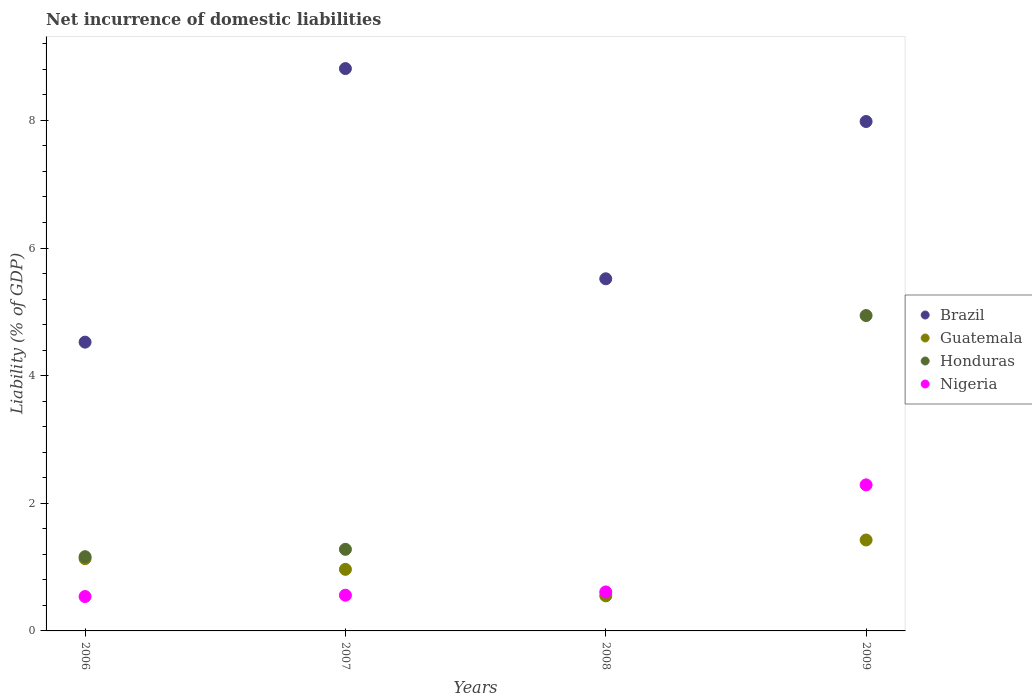How many different coloured dotlines are there?
Offer a terse response. 4. Is the number of dotlines equal to the number of legend labels?
Make the answer very short. No. What is the net incurrence of domestic liabilities in Brazil in 2009?
Make the answer very short. 7.98. Across all years, what is the maximum net incurrence of domestic liabilities in Guatemala?
Keep it short and to the point. 1.42. Across all years, what is the minimum net incurrence of domestic liabilities in Brazil?
Ensure brevity in your answer.  4.53. What is the total net incurrence of domestic liabilities in Brazil in the graph?
Offer a very short reply. 26.84. What is the difference between the net incurrence of domestic liabilities in Honduras in 2006 and that in 2009?
Provide a succinct answer. -3.78. What is the difference between the net incurrence of domestic liabilities in Brazil in 2006 and the net incurrence of domestic liabilities in Honduras in 2009?
Your answer should be compact. -0.42. What is the average net incurrence of domestic liabilities in Guatemala per year?
Provide a short and direct response. 1.02. In the year 2009, what is the difference between the net incurrence of domestic liabilities in Honduras and net incurrence of domestic liabilities in Nigeria?
Offer a very short reply. 2.65. What is the ratio of the net incurrence of domestic liabilities in Brazil in 2008 to that in 2009?
Provide a short and direct response. 0.69. Is the net incurrence of domestic liabilities in Brazil in 2006 less than that in 2009?
Offer a terse response. Yes. What is the difference between the highest and the second highest net incurrence of domestic liabilities in Guatemala?
Your answer should be compact. 0.29. What is the difference between the highest and the lowest net incurrence of domestic liabilities in Nigeria?
Make the answer very short. 1.75. Is the sum of the net incurrence of domestic liabilities in Honduras in 2007 and 2009 greater than the maximum net incurrence of domestic liabilities in Nigeria across all years?
Ensure brevity in your answer.  Yes. Does the net incurrence of domestic liabilities in Nigeria monotonically increase over the years?
Your response must be concise. Yes. Is the net incurrence of domestic liabilities in Brazil strictly greater than the net incurrence of domestic liabilities in Honduras over the years?
Your answer should be very brief. Yes. Is the net incurrence of domestic liabilities in Brazil strictly less than the net incurrence of domestic liabilities in Nigeria over the years?
Provide a short and direct response. No. What is the difference between two consecutive major ticks on the Y-axis?
Offer a terse response. 2. Are the values on the major ticks of Y-axis written in scientific E-notation?
Your answer should be very brief. No. Does the graph contain any zero values?
Your response must be concise. Yes. Does the graph contain grids?
Make the answer very short. No. How many legend labels are there?
Provide a short and direct response. 4. How are the legend labels stacked?
Provide a short and direct response. Vertical. What is the title of the graph?
Give a very brief answer. Net incurrence of domestic liabilities. Does "Papua New Guinea" appear as one of the legend labels in the graph?
Keep it short and to the point. No. What is the label or title of the X-axis?
Make the answer very short. Years. What is the label or title of the Y-axis?
Offer a terse response. Liability (% of GDP). What is the Liability (% of GDP) in Brazil in 2006?
Make the answer very short. 4.53. What is the Liability (% of GDP) of Guatemala in 2006?
Provide a short and direct response. 1.13. What is the Liability (% of GDP) of Honduras in 2006?
Keep it short and to the point. 1.16. What is the Liability (% of GDP) of Nigeria in 2006?
Offer a very short reply. 0.54. What is the Liability (% of GDP) in Brazil in 2007?
Offer a very short reply. 8.81. What is the Liability (% of GDP) in Guatemala in 2007?
Provide a short and direct response. 0.96. What is the Liability (% of GDP) in Honduras in 2007?
Keep it short and to the point. 1.28. What is the Liability (% of GDP) of Nigeria in 2007?
Give a very brief answer. 0.56. What is the Liability (% of GDP) in Brazil in 2008?
Keep it short and to the point. 5.52. What is the Liability (% of GDP) in Guatemala in 2008?
Give a very brief answer. 0.55. What is the Liability (% of GDP) in Honduras in 2008?
Provide a succinct answer. 0. What is the Liability (% of GDP) of Nigeria in 2008?
Make the answer very short. 0.61. What is the Liability (% of GDP) of Brazil in 2009?
Ensure brevity in your answer.  7.98. What is the Liability (% of GDP) in Guatemala in 2009?
Keep it short and to the point. 1.42. What is the Liability (% of GDP) of Honduras in 2009?
Make the answer very short. 4.94. What is the Liability (% of GDP) in Nigeria in 2009?
Offer a very short reply. 2.29. Across all years, what is the maximum Liability (% of GDP) in Brazil?
Keep it short and to the point. 8.81. Across all years, what is the maximum Liability (% of GDP) of Guatemala?
Your answer should be compact. 1.42. Across all years, what is the maximum Liability (% of GDP) in Honduras?
Your answer should be compact. 4.94. Across all years, what is the maximum Liability (% of GDP) of Nigeria?
Make the answer very short. 2.29. Across all years, what is the minimum Liability (% of GDP) in Brazil?
Give a very brief answer. 4.53. Across all years, what is the minimum Liability (% of GDP) in Guatemala?
Keep it short and to the point. 0.55. Across all years, what is the minimum Liability (% of GDP) of Nigeria?
Provide a succinct answer. 0.54. What is the total Liability (% of GDP) of Brazil in the graph?
Your answer should be very brief. 26.84. What is the total Liability (% of GDP) of Guatemala in the graph?
Your response must be concise. 4.07. What is the total Liability (% of GDP) in Honduras in the graph?
Your answer should be very brief. 7.38. What is the total Liability (% of GDP) in Nigeria in the graph?
Make the answer very short. 4. What is the difference between the Liability (% of GDP) in Brazil in 2006 and that in 2007?
Make the answer very short. -4.29. What is the difference between the Liability (% of GDP) of Guatemala in 2006 and that in 2007?
Keep it short and to the point. 0.17. What is the difference between the Liability (% of GDP) of Honduras in 2006 and that in 2007?
Your response must be concise. -0.12. What is the difference between the Liability (% of GDP) in Nigeria in 2006 and that in 2007?
Provide a short and direct response. -0.02. What is the difference between the Liability (% of GDP) in Brazil in 2006 and that in 2008?
Make the answer very short. -0.99. What is the difference between the Liability (% of GDP) of Guatemala in 2006 and that in 2008?
Your answer should be very brief. 0.58. What is the difference between the Liability (% of GDP) in Nigeria in 2006 and that in 2008?
Your answer should be compact. -0.07. What is the difference between the Liability (% of GDP) in Brazil in 2006 and that in 2009?
Your answer should be compact. -3.46. What is the difference between the Liability (% of GDP) in Guatemala in 2006 and that in 2009?
Your answer should be very brief. -0.29. What is the difference between the Liability (% of GDP) in Honduras in 2006 and that in 2009?
Give a very brief answer. -3.78. What is the difference between the Liability (% of GDP) in Nigeria in 2006 and that in 2009?
Give a very brief answer. -1.75. What is the difference between the Liability (% of GDP) of Brazil in 2007 and that in 2008?
Keep it short and to the point. 3.29. What is the difference between the Liability (% of GDP) of Guatemala in 2007 and that in 2008?
Ensure brevity in your answer.  0.42. What is the difference between the Liability (% of GDP) in Nigeria in 2007 and that in 2008?
Ensure brevity in your answer.  -0.05. What is the difference between the Liability (% of GDP) in Brazil in 2007 and that in 2009?
Provide a short and direct response. 0.83. What is the difference between the Liability (% of GDP) in Guatemala in 2007 and that in 2009?
Offer a terse response. -0.46. What is the difference between the Liability (% of GDP) in Honduras in 2007 and that in 2009?
Your answer should be very brief. -3.66. What is the difference between the Liability (% of GDP) in Nigeria in 2007 and that in 2009?
Provide a short and direct response. -1.73. What is the difference between the Liability (% of GDP) of Brazil in 2008 and that in 2009?
Give a very brief answer. -2.46. What is the difference between the Liability (% of GDP) of Guatemala in 2008 and that in 2009?
Keep it short and to the point. -0.88. What is the difference between the Liability (% of GDP) in Nigeria in 2008 and that in 2009?
Provide a short and direct response. -1.68. What is the difference between the Liability (% of GDP) in Brazil in 2006 and the Liability (% of GDP) in Guatemala in 2007?
Make the answer very short. 3.56. What is the difference between the Liability (% of GDP) of Brazil in 2006 and the Liability (% of GDP) of Honduras in 2007?
Your answer should be compact. 3.25. What is the difference between the Liability (% of GDP) in Brazil in 2006 and the Liability (% of GDP) in Nigeria in 2007?
Keep it short and to the point. 3.97. What is the difference between the Liability (% of GDP) of Guatemala in 2006 and the Liability (% of GDP) of Honduras in 2007?
Offer a terse response. -0.15. What is the difference between the Liability (% of GDP) of Guatemala in 2006 and the Liability (% of GDP) of Nigeria in 2007?
Your answer should be very brief. 0.57. What is the difference between the Liability (% of GDP) of Honduras in 2006 and the Liability (% of GDP) of Nigeria in 2007?
Your answer should be compact. 0.6. What is the difference between the Liability (% of GDP) of Brazil in 2006 and the Liability (% of GDP) of Guatemala in 2008?
Make the answer very short. 3.98. What is the difference between the Liability (% of GDP) of Brazil in 2006 and the Liability (% of GDP) of Nigeria in 2008?
Offer a very short reply. 3.91. What is the difference between the Liability (% of GDP) in Guatemala in 2006 and the Liability (% of GDP) in Nigeria in 2008?
Provide a short and direct response. 0.52. What is the difference between the Liability (% of GDP) in Honduras in 2006 and the Liability (% of GDP) in Nigeria in 2008?
Give a very brief answer. 0.55. What is the difference between the Liability (% of GDP) in Brazil in 2006 and the Liability (% of GDP) in Guatemala in 2009?
Your answer should be very brief. 3.1. What is the difference between the Liability (% of GDP) of Brazil in 2006 and the Liability (% of GDP) of Honduras in 2009?
Give a very brief answer. -0.42. What is the difference between the Liability (% of GDP) of Brazil in 2006 and the Liability (% of GDP) of Nigeria in 2009?
Give a very brief answer. 2.24. What is the difference between the Liability (% of GDP) in Guatemala in 2006 and the Liability (% of GDP) in Honduras in 2009?
Your response must be concise. -3.81. What is the difference between the Liability (% of GDP) of Guatemala in 2006 and the Liability (% of GDP) of Nigeria in 2009?
Keep it short and to the point. -1.16. What is the difference between the Liability (% of GDP) of Honduras in 2006 and the Liability (% of GDP) of Nigeria in 2009?
Provide a short and direct response. -1.13. What is the difference between the Liability (% of GDP) in Brazil in 2007 and the Liability (% of GDP) in Guatemala in 2008?
Offer a terse response. 8.26. What is the difference between the Liability (% of GDP) in Brazil in 2007 and the Liability (% of GDP) in Nigeria in 2008?
Keep it short and to the point. 8.2. What is the difference between the Liability (% of GDP) of Guatemala in 2007 and the Liability (% of GDP) of Nigeria in 2008?
Offer a very short reply. 0.35. What is the difference between the Liability (% of GDP) of Honduras in 2007 and the Liability (% of GDP) of Nigeria in 2008?
Offer a very short reply. 0.67. What is the difference between the Liability (% of GDP) in Brazil in 2007 and the Liability (% of GDP) in Guatemala in 2009?
Provide a succinct answer. 7.39. What is the difference between the Liability (% of GDP) in Brazil in 2007 and the Liability (% of GDP) in Honduras in 2009?
Provide a short and direct response. 3.87. What is the difference between the Liability (% of GDP) of Brazil in 2007 and the Liability (% of GDP) of Nigeria in 2009?
Your response must be concise. 6.52. What is the difference between the Liability (% of GDP) of Guatemala in 2007 and the Liability (% of GDP) of Honduras in 2009?
Your response must be concise. -3.98. What is the difference between the Liability (% of GDP) of Guatemala in 2007 and the Liability (% of GDP) of Nigeria in 2009?
Give a very brief answer. -1.32. What is the difference between the Liability (% of GDP) in Honduras in 2007 and the Liability (% of GDP) in Nigeria in 2009?
Keep it short and to the point. -1.01. What is the difference between the Liability (% of GDP) of Brazil in 2008 and the Liability (% of GDP) of Guatemala in 2009?
Give a very brief answer. 4.09. What is the difference between the Liability (% of GDP) in Brazil in 2008 and the Liability (% of GDP) in Honduras in 2009?
Make the answer very short. 0.58. What is the difference between the Liability (% of GDP) in Brazil in 2008 and the Liability (% of GDP) in Nigeria in 2009?
Ensure brevity in your answer.  3.23. What is the difference between the Liability (% of GDP) in Guatemala in 2008 and the Liability (% of GDP) in Honduras in 2009?
Give a very brief answer. -4.39. What is the difference between the Liability (% of GDP) in Guatemala in 2008 and the Liability (% of GDP) in Nigeria in 2009?
Offer a terse response. -1.74. What is the average Liability (% of GDP) in Brazil per year?
Offer a very short reply. 6.71. What is the average Liability (% of GDP) in Honduras per year?
Ensure brevity in your answer.  1.85. In the year 2006, what is the difference between the Liability (% of GDP) in Brazil and Liability (% of GDP) in Guatemala?
Your response must be concise. 3.39. In the year 2006, what is the difference between the Liability (% of GDP) of Brazil and Liability (% of GDP) of Honduras?
Keep it short and to the point. 3.36. In the year 2006, what is the difference between the Liability (% of GDP) in Brazil and Liability (% of GDP) in Nigeria?
Make the answer very short. 3.99. In the year 2006, what is the difference between the Liability (% of GDP) in Guatemala and Liability (% of GDP) in Honduras?
Provide a succinct answer. -0.03. In the year 2006, what is the difference between the Liability (% of GDP) in Guatemala and Liability (% of GDP) in Nigeria?
Make the answer very short. 0.59. In the year 2006, what is the difference between the Liability (% of GDP) of Honduras and Liability (% of GDP) of Nigeria?
Make the answer very short. 0.62. In the year 2007, what is the difference between the Liability (% of GDP) in Brazil and Liability (% of GDP) in Guatemala?
Offer a very short reply. 7.85. In the year 2007, what is the difference between the Liability (% of GDP) of Brazil and Liability (% of GDP) of Honduras?
Provide a short and direct response. 7.53. In the year 2007, what is the difference between the Liability (% of GDP) of Brazil and Liability (% of GDP) of Nigeria?
Provide a short and direct response. 8.25. In the year 2007, what is the difference between the Liability (% of GDP) of Guatemala and Liability (% of GDP) of Honduras?
Provide a succinct answer. -0.31. In the year 2007, what is the difference between the Liability (% of GDP) in Guatemala and Liability (% of GDP) in Nigeria?
Your answer should be compact. 0.41. In the year 2007, what is the difference between the Liability (% of GDP) in Honduras and Liability (% of GDP) in Nigeria?
Keep it short and to the point. 0.72. In the year 2008, what is the difference between the Liability (% of GDP) in Brazil and Liability (% of GDP) in Guatemala?
Make the answer very short. 4.97. In the year 2008, what is the difference between the Liability (% of GDP) of Brazil and Liability (% of GDP) of Nigeria?
Keep it short and to the point. 4.91. In the year 2008, what is the difference between the Liability (% of GDP) of Guatemala and Liability (% of GDP) of Nigeria?
Provide a short and direct response. -0.06. In the year 2009, what is the difference between the Liability (% of GDP) of Brazil and Liability (% of GDP) of Guatemala?
Give a very brief answer. 6.56. In the year 2009, what is the difference between the Liability (% of GDP) of Brazil and Liability (% of GDP) of Honduras?
Offer a very short reply. 3.04. In the year 2009, what is the difference between the Liability (% of GDP) of Brazil and Liability (% of GDP) of Nigeria?
Ensure brevity in your answer.  5.69. In the year 2009, what is the difference between the Liability (% of GDP) of Guatemala and Liability (% of GDP) of Honduras?
Offer a very short reply. -3.52. In the year 2009, what is the difference between the Liability (% of GDP) of Guatemala and Liability (% of GDP) of Nigeria?
Keep it short and to the point. -0.86. In the year 2009, what is the difference between the Liability (% of GDP) in Honduras and Liability (% of GDP) in Nigeria?
Give a very brief answer. 2.65. What is the ratio of the Liability (% of GDP) of Brazil in 2006 to that in 2007?
Your answer should be compact. 0.51. What is the ratio of the Liability (% of GDP) in Guatemala in 2006 to that in 2007?
Ensure brevity in your answer.  1.17. What is the ratio of the Liability (% of GDP) of Honduras in 2006 to that in 2007?
Give a very brief answer. 0.91. What is the ratio of the Liability (% of GDP) of Nigeria in 2006 to that in 2007?
Your response must be concise. 0.96. What is the ratio of the Liability (% of GDP) of Brazil in 2006 to that in 2008?
Offer a very short reply. 0.82. What is the ratio of the Liability (% of GDP) of Guatemala in 2006 to that in 2008?
Keep it short and to the point. 2.06. What is the ratio of the Liability (% of GDP) in Nigeria in 2006 to that in 2008?
Your response must be concise. 0.88. What is the ratio of the Liability (% of GDP) of Brazil in 2006 to that in 2009?
Provide a succinct answer. 0.57. What is the ratio of the Liability (% of GDP) of Guatemala in 2006 to that in 2009?
Provide a succinct answer. 0.8. What is the ratio of the Liability (% of GDP) in Honduras in 2006 to that in 2009?
Your answer should be very brief. 0.24. What is the ratio of the Liability (% of GDP) of Nigeria in 2006 to that in 2009?
Provide a succinct answer. 0.24. What is the ratio of the Liability (% of GDP) of Brazil in 2007 to that in 2008?
Provide a succinct answer. 1.6. What is the ratio of the Liability (% of GDP) in Guatemala in 2007 to that in 2008?
Your answer should be very brief. 1.76. What is the ratio of the Liability (% of GDP) of Nigeria in 2007 to that in 2008?
Provide a short and direct response. 0.92. What is the ratio of the Liability (% of GDP) in Brazil in 2007 to that in 2009?
Ensure brevity in your answer.  1.1. What is the ratio of the Liability (% of GDP) of Guatemala in 2007 to that in 2009?
Give a very brief answer. 0.68. What is the ratio of the Liability (% of GDP) in Honduras in 2007 to that in 2009?
Ensure brevity in your answer.  0.26. What is the ratio of the Liability (% of GDP) in Nigeria in 2007 to that in 2009?
Offer a very short reply. 0.24. What is the ratio of the Liability (% of GDP) of Brazil in 2008 to that in 2009?
Provide a short and direct response. 0.69. What is the ratio of the Liability (% of GDP) in Guatemala in 2008 to that in 2009?
Give a very brief answer. 0.39. What is the ratio of the Liability (% of GDP) in Nigeria in 2008 to that in 2009?
Offer a terse response. 0.27. What is the difference between the highest and the second highest Liability (% of GDP) in Brazil?
Your answer should be very brief. 0.83. What is the difference between the highest and the second highest Liability (% of GDP) in Guatemala?
Offer a very short reply. 0.29. What is the difference between the highest and the second highest Liability (% of GDP) in Honduras?
Give a very brief answer. 3.66. What is the difference between the highest and the second highest Liability (% of GDP) of Nigeria?
Your answer should be compact. 1.68. What is the difference between the highest and the lowest Liability (% of GDP) of Brazil?
Provide a short and direct response. 4.29. What is the difference between the highest and the lowest Liability (% of GDP) of Guatemala?
Give a very brief answer. 0.88. What is the difference between the highest and the lowest Liability (% of GDP) of Honduras?
Your answer should be very brief. 4.94. What is the difference between the highest and the lowest Liability (% of GDP) in Nigeria?
Make the answer very short. 1.75. 